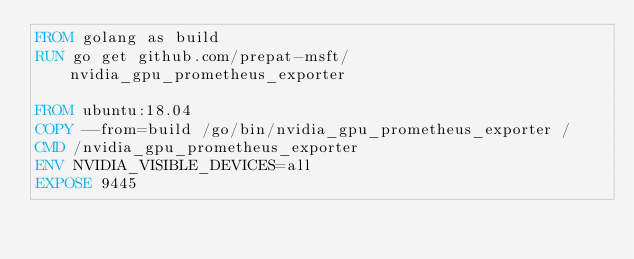<code> <loc_0><loc_0><loc_500><loc_500><_Dockerfile_>FROM golang as build
RUN go get github.com/prepat-msft/nvidia_gpu_prometheus_exporter

FROM ubuntu:18.04
COPY --from=build /go/bin/nvidia_gpu_prometheus_exporter /
CMD /nvidia_gpu_prometheus_exporter
ENV NVIDIA_VISIBLE_DEVICES=all
EXPOSE 9445
</code> 